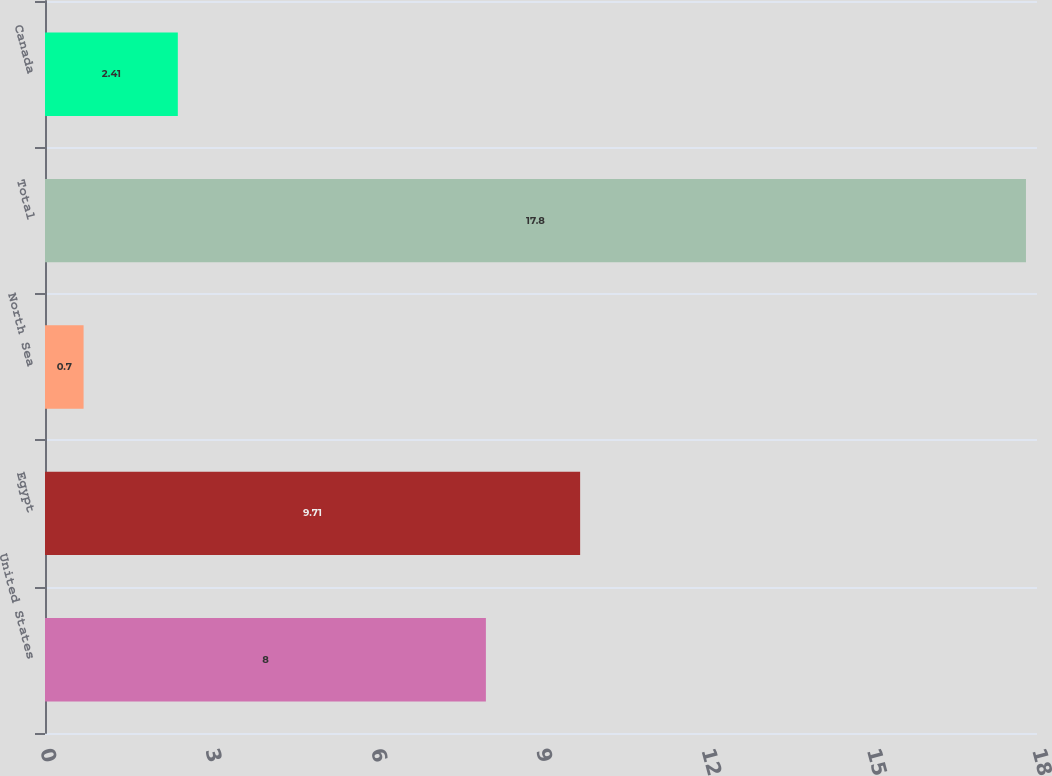<chart> <loc_0><loc_0><loc_500><loc_500><bar_chart><fcel>United States<fcel>Egypt<fcel>North Sea<fcel>Total<fcel>Canada<nl><fcel>8<fcel>9.71<fcel>0.7<fcel>17.8<fcel>2.41<nl></chart> 